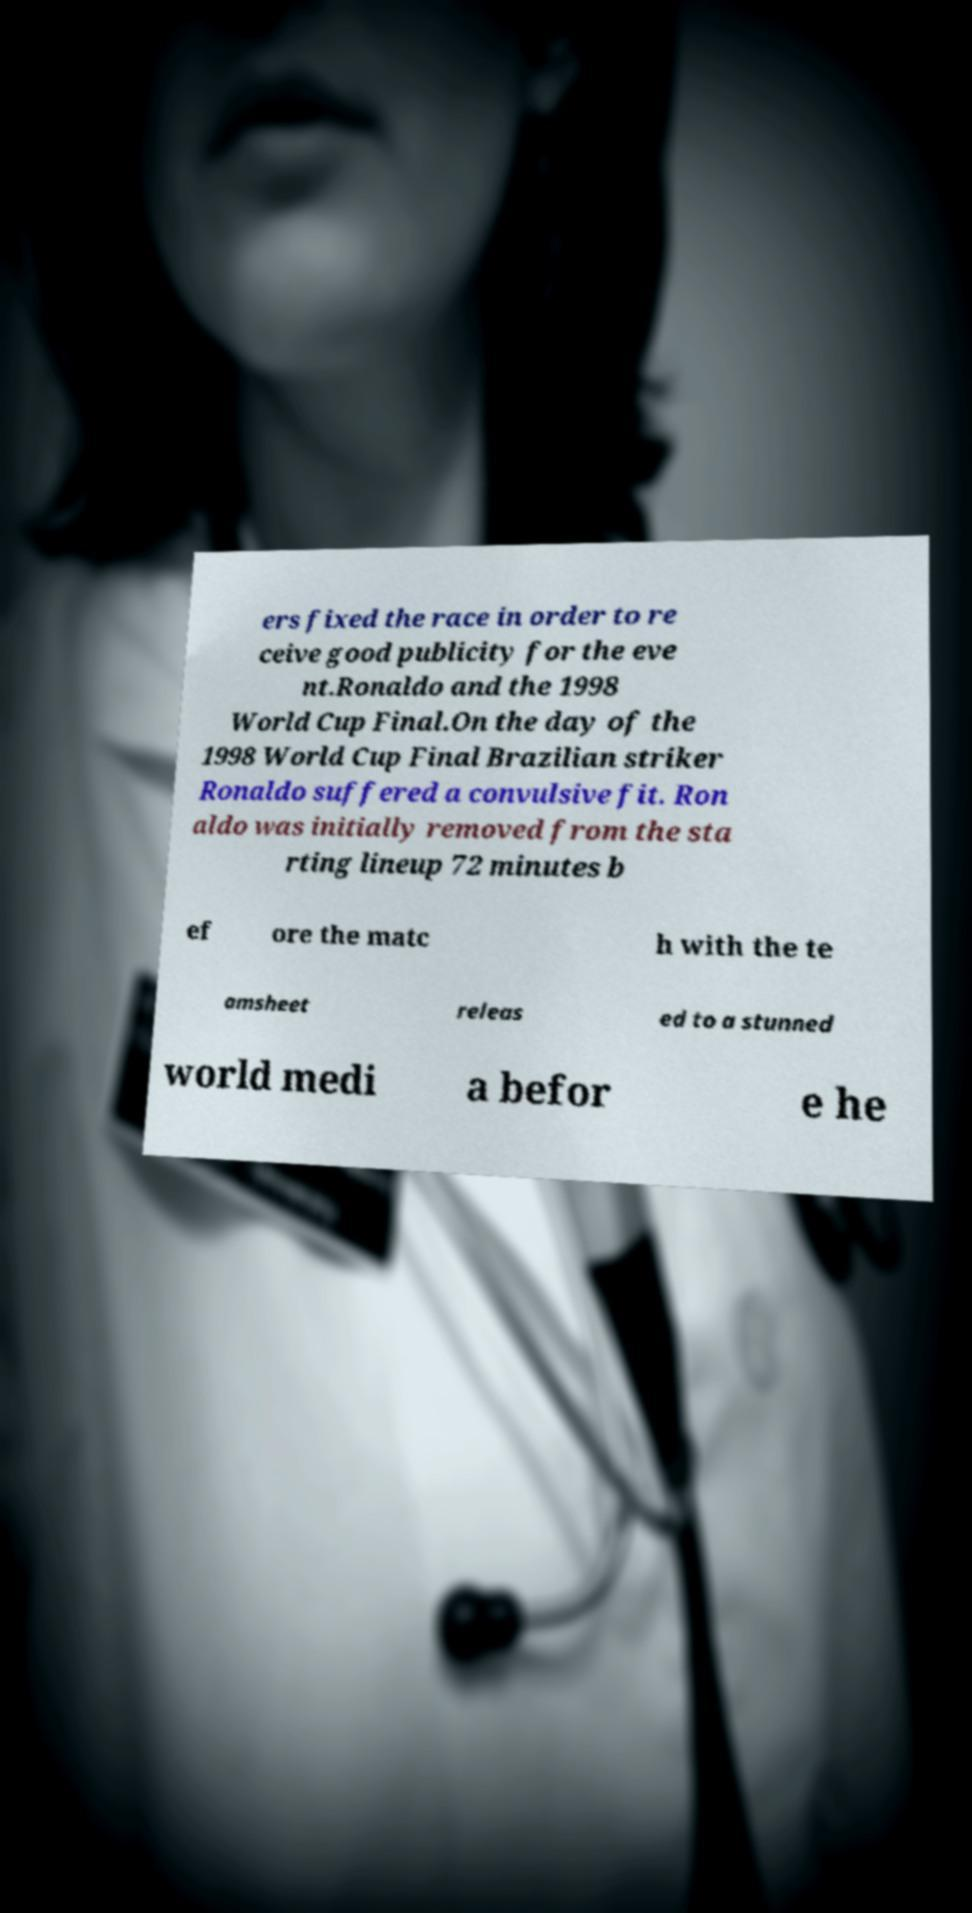There's text embedded in this image that I need extracted. Can you transcribe it verbatim? ers fixed the race in order to re ceive good publicity for the eve nt.Ronaldo and the 1998 World Cup Final.On the day of the 1998 World Cup Final Brazilian striker Ronaldo suffered a convulsive fit. Ron aldo was initially removed from the sta rting lineup 72 minutes b ef ore the matc h with the te amsheet releas ed to a stunned world medi a befor e he 